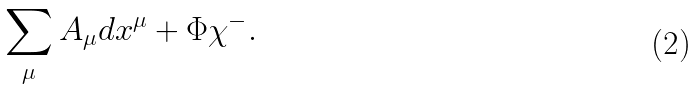Convert formula to latex. <formula><loc_0><loc_0><loc_500><loc_500>\sum _ { \mu } A _ { \mu } d x ^ { \mu } + \Phi \chi ^ { - } .</formula> 